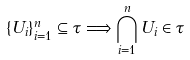Convert formula to latex. <formula><loc_0><loc_0><loc_500><loc_500>\{ U _ { i } \} _ { i = 1 } ^ { n } \subseteq \tau \Longrightarrow \bigcap _ { i = 1 } ^ { n } U _ { i } \in \tau</formula> 